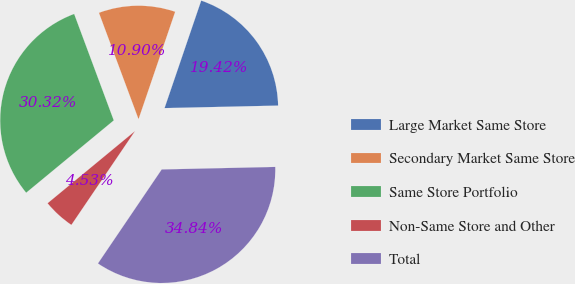Convert chart to OTSL. <chart><loc_0><loc_0><loc_500><loc_500><pie_chart><fcel>Large Market Same Store<fcel>Secondary Market Same Store<fcel>Same Store Portfolio<fcel>Non-Same Store and Other<fcel>Total<nl><fcel>19.42%<fcel>10.9%<fcel>30.32%<fcel>4.53%<fcel>34.84%<nl></chart> 